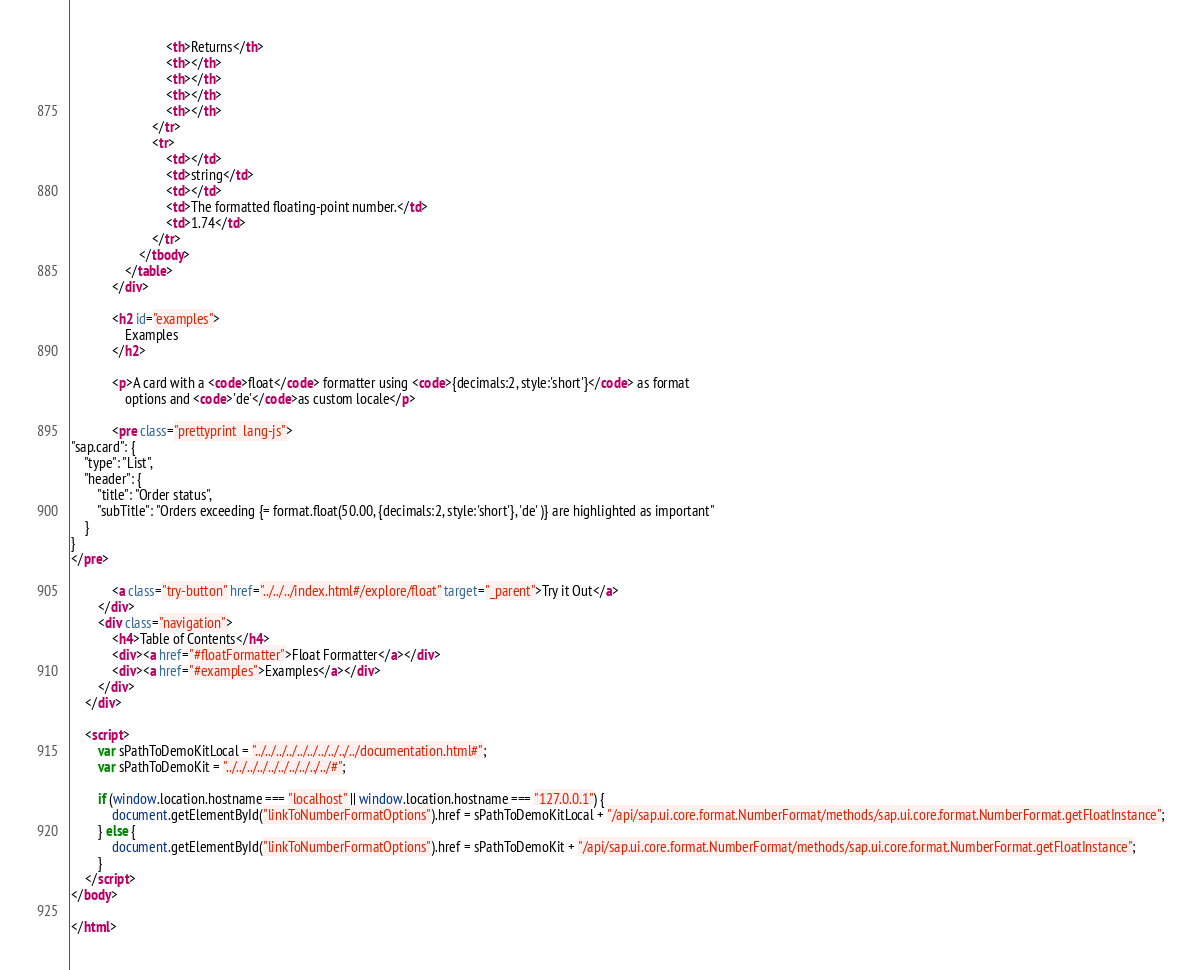Convert code to text. <code><loc_0><loc_0><loc_500><loc_500><_HTML_>							<th>Returns</th>
							<th></th>
							<th></th>
							<th></th>
							<th></th>
						</tr>
						<tr>
							<td></td>
							<td>string</td>
							<td></td>
							<td>The formatted floating-point number.</td>
							<td>1.74</td>
						</tr>
					</tbody>
				</table>
			</div>

			<h2 id="examples">
				Examples
			</h2>

			<p>A card with a <code>float</code> formatter using <code>{decimals:2, style:'short'}</code> as format
				options and <code>'de'</code>as custom locale</p>

			<pre class="prettyprint  lang-js">
"sap.card": {
	"type": "List",
	"header": {
		"title": "Order status",
		"subTitle": "Orders exceeding {= format.float(50.00, {decimals:2, style:'short'}, 'de' )} are highlighted as important"
	}
}
</pre>

			<a class="try-button" href="../../../index.html#/explore/float" target="_parent">Try it Out</a>
		</div>
		<div class="navigation">
			<h4>Table of Contents</h4>
			<div><a href="#floatFormatter">Float Formatter</a></div>
			<div><a href="#examples">Examples</a></div>
		</div>
	</div>

	<script>
		var sPathToDemoKitLocal = "../../../../../../../../../../documentation.html#";
		var sPathToDemoKit = "../../../../../../../../../../#";

		if (window.location.hostname === "localhost" || window.location.hostname === "127.0.0.1") {
			document.getElementById("linkToNumberFormatOptions").href = sPathToDemoKitLocal + "/api/sap.ui.core.format.NumberFormat/methods/sap.ui.core.format.NumberFormat.getFloatInstance";
		} else {
			document.getElementById("linkToNumberFormatOptions").href = sPathToDemoKit + "/api/sap.ui.core.format.NumberFormat/methods/sap.ui.core.format.NumberFormat.getFloatInstance";
		}
	</script>
</body>

</html></code> 